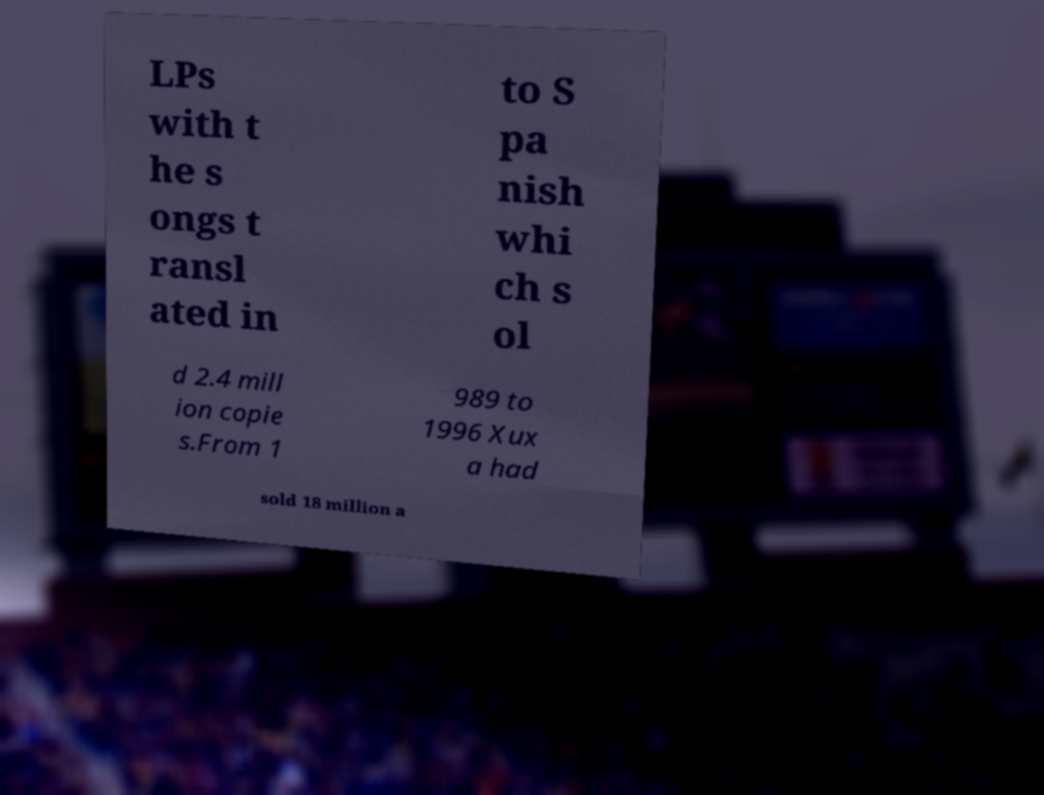There's text embedded in this image that I need extracted. Can you transcribe it verbatim? LPs with t he s ongs t ransl ated in to S pa nish whi ch s ol d 2.4 mill ion copie s.From 1 989 to 1996 Xux a had sold 18 million a 